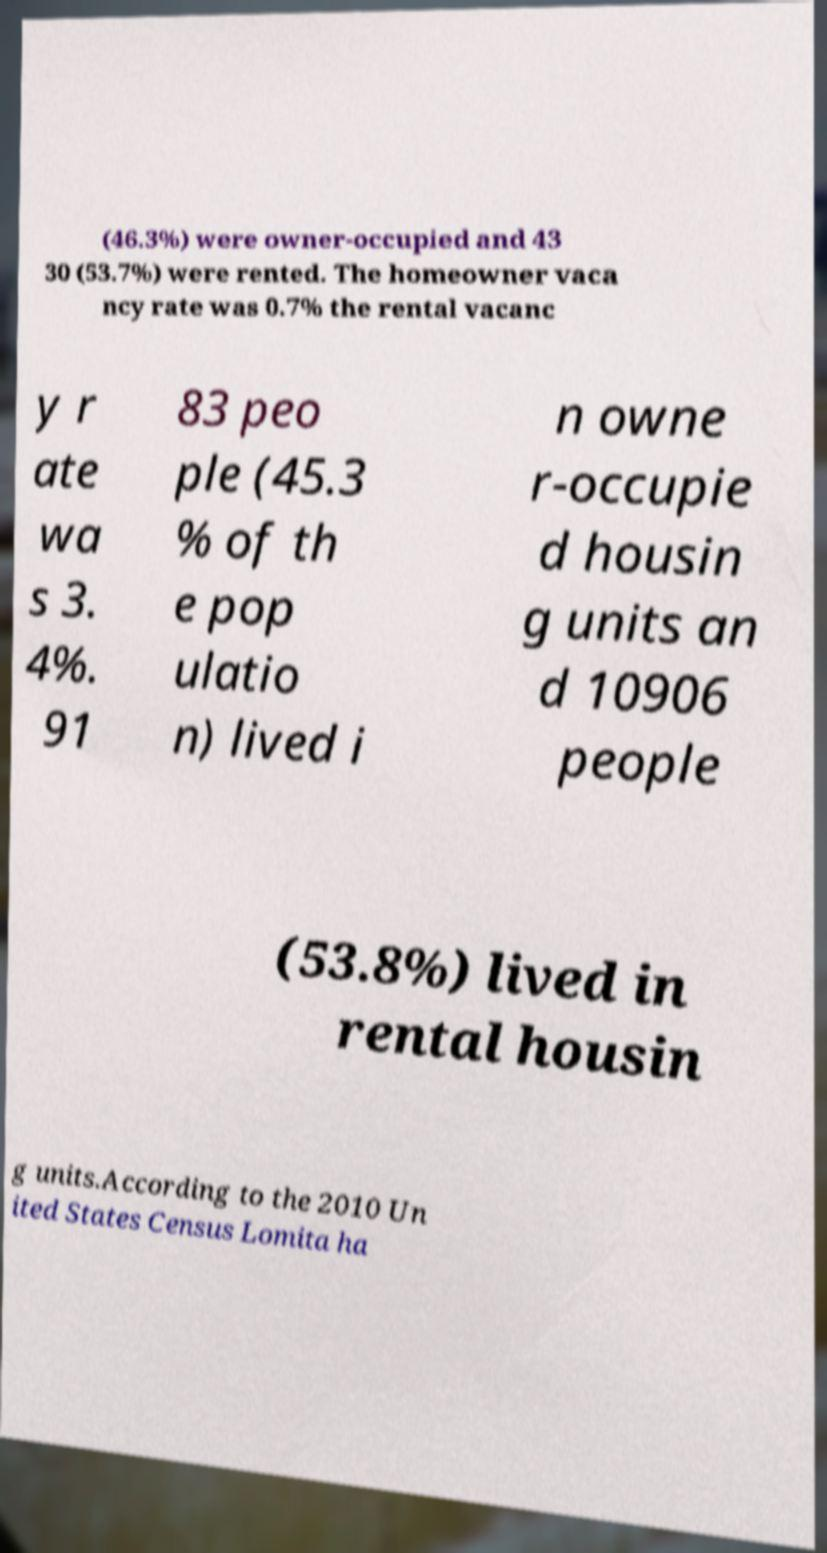Please identify and transcribe the text found in this image. (46.3%) were owner-occupied and 43 30 (53.7%) were rented. The homeowner vaca ncy rate was 0.7% the rental vacanc y r ate wa s 3. 4%. 91 83 peo ple (45.3 % of th e pop ulatio n) lived i n owne r-occupie d housin g units an d 10906 people (53.8%) lived in rental housin g units.According to the 2010 Un ited States Census Lomita ha 